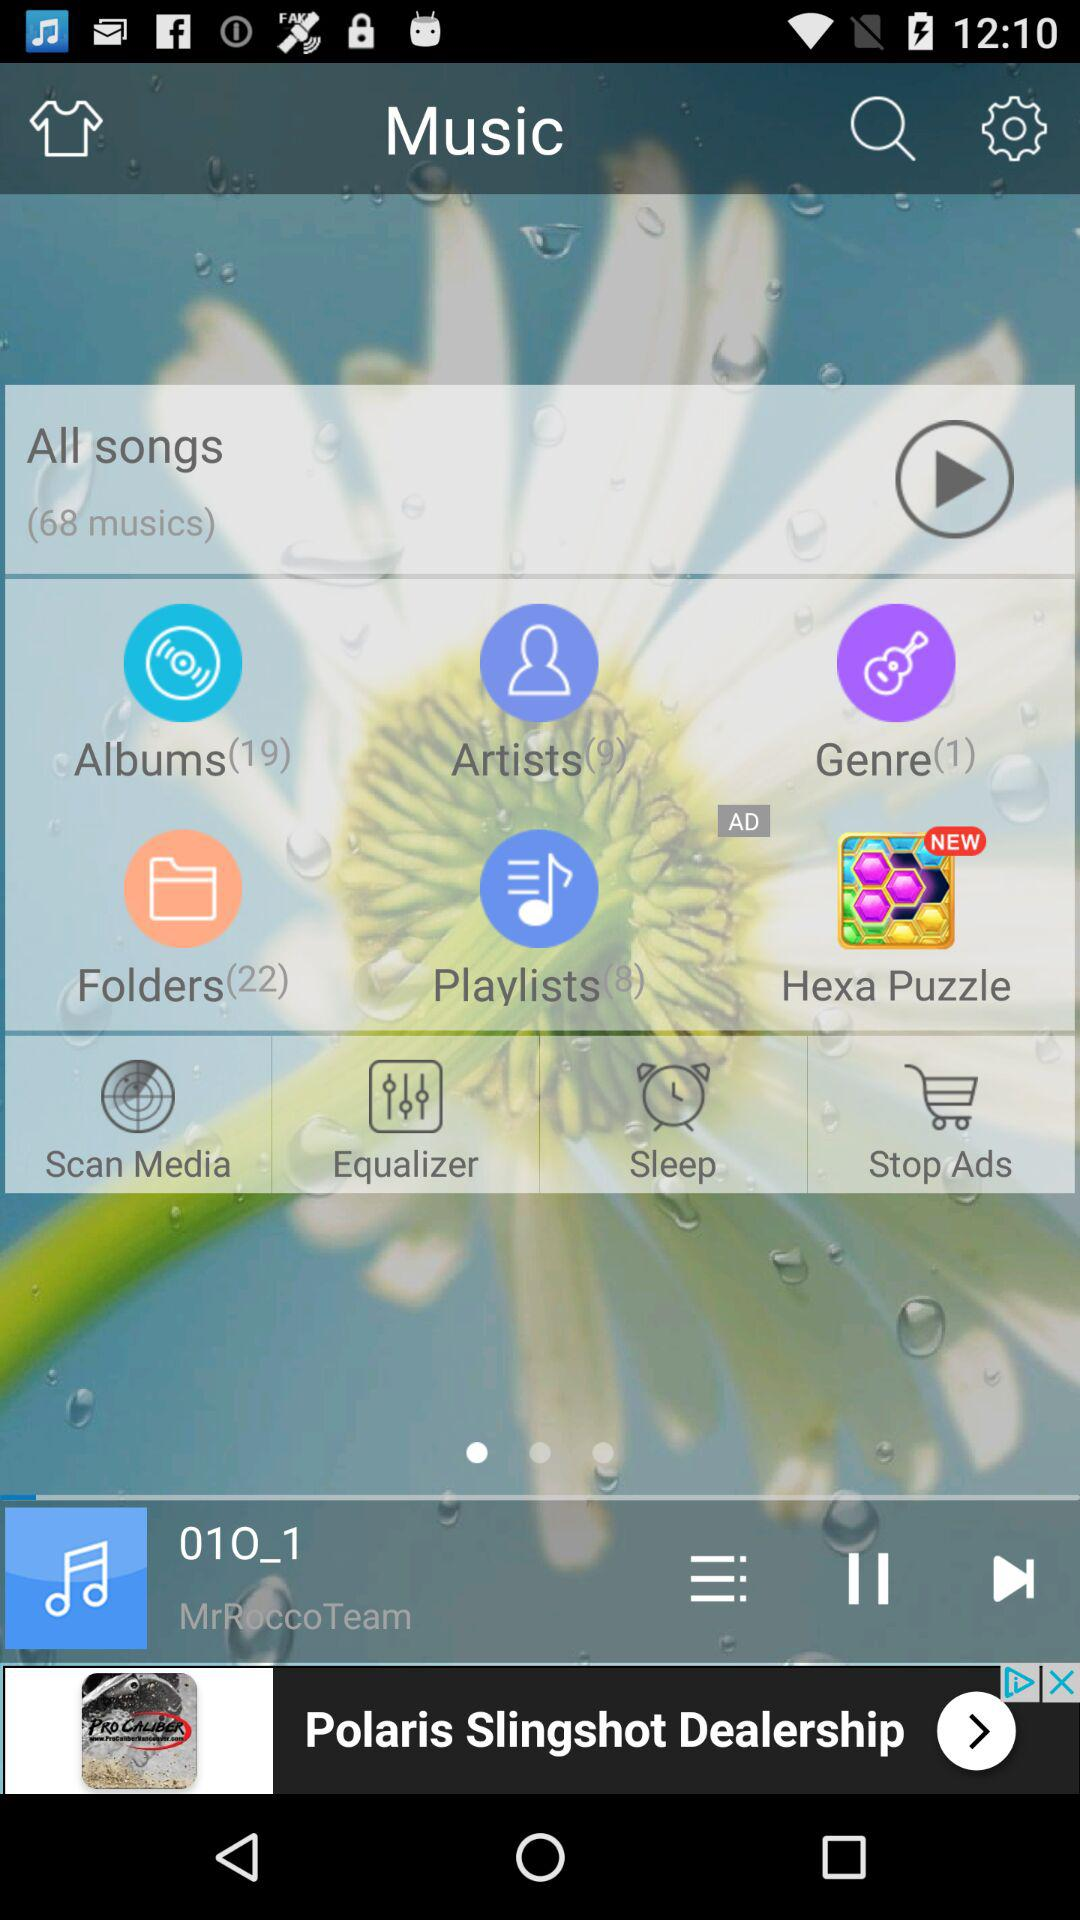How many playlists are there? There are 8 playlists. 